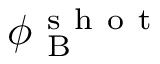<formula> <loc_0><loc_0><loc_500><loc_500>\phi _ { B } ^ { s h o t }</formula> 